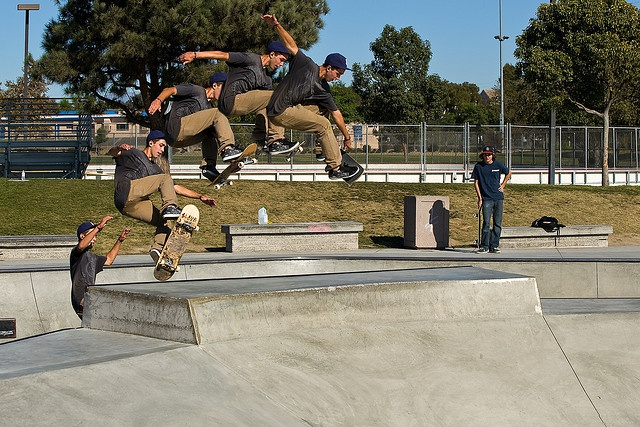Describe the objects in this image and their specific colors. I can see people in lightblue, black, tan, gray, and maroon tones, people in lightblue, black, tan, and gray tones, people in lightblue, black, tan, gray, and olive tones, people in lightblue, black, gray, and tan tones, and bench in lightblue, darkgray, tan, and black tones in this image. 